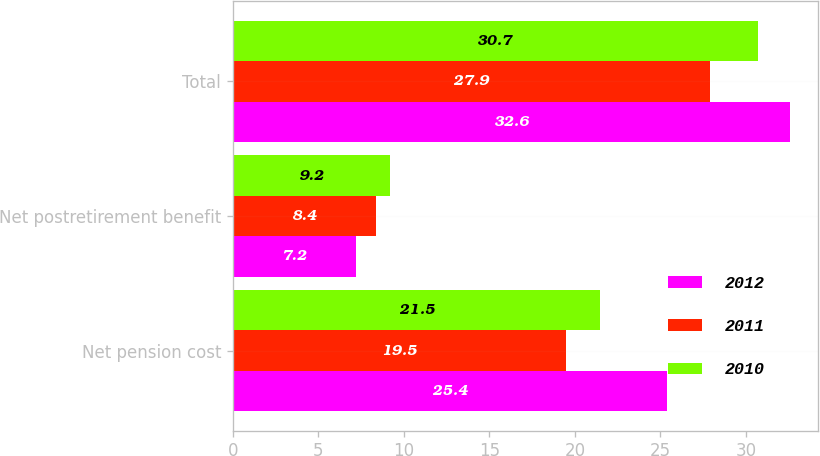<chart> <loc_0><loc_0><loc_500><loc_500><stacked_bar_chart><ecel><fcel>Net pension cost<fcel>Net postretirement benefit<fcel>Total<nl><fcel>2012<fcel>25.4<fcel>7.2<fcel>32.6<nl><fcel>2011<fcel>19.5<fcel>8.4<fcel>27.9<nl><fcel>2010<fcel>21.5<fcel>9.2<fcel>30.7<nl></chart> 